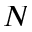<formula> <loc_0><loc_0><loc_500><loc_500>N</formula> 